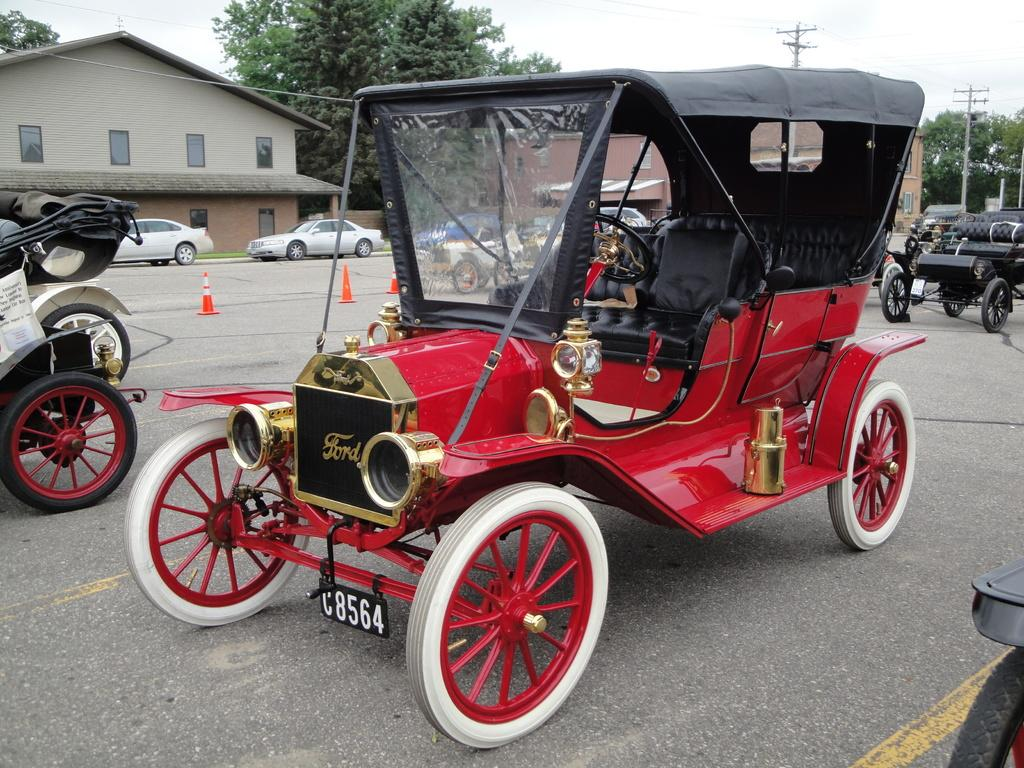What can be seen on the road in the image? There are vehicles on the road in the image. What objects are present to control traffic or indicate a construction area? There are cone barricades in the image. What structures can be seen in the image? There are poles and houses in the image. What type of vegetation is present in the image? There are trees in the image. What is visible in the background of the image? The sky is visible in the background of the image. Can you tell me how many quinces are hanging from the trees in the image? There are no quinces present in the image; it features trees without any specific fruits mentioned. Is there a donkey walking along the road in the image? There is no donkey present in the image; it only shows vehicles on the road. 